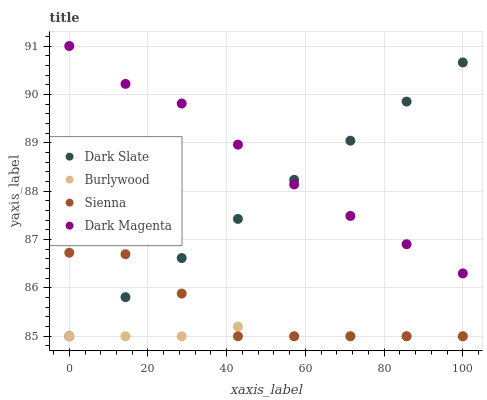Does Burlywood have the minimum area under the curve?
Answer yes or no. Yes. Does Dark Magenta have the maximum area under the curve?
Answer yes or no. Yes. Does Dark Slate have the minimum area under the curve?
Answer yes or no. No. Does Dark Slate have the maximum area under the curve?
Answer yes or no. No. Is Dark Slate the smoothest?
Answer yes or no. Yes. Is Sienna the roughest?
Answer yes or no. Yes. Is Dark Magenta the smoothest?
Answer yes or no. No. Is Dark Magenta the roughest?
Answer yes or no. No. Does Burlywood have the lowest value?
Answer yes or no. Yes. Does Dark Magenta have the lowest value?
Answer yes or no. No. Does Dark Magenta have the highest value?
Answer yes or no. Yes. Does Dark Slate have the highest value?
Answer yes or no. No. Is Sienna less than Dark Magenta?
Answer yes or no. Yes. Is Dark Magenta greater than Sienna?
Answer yes or no. Yes. Does Burlywood intersect Sienna?
Answer yes or no. Yes. Is Burlywood less than Sienna?
Answer yes or no. No. Is Burlywood greater than Sienna?
Answer yes or no. No. Does Sienna intersect Dark Magenta?
Answer yes or no. No. 